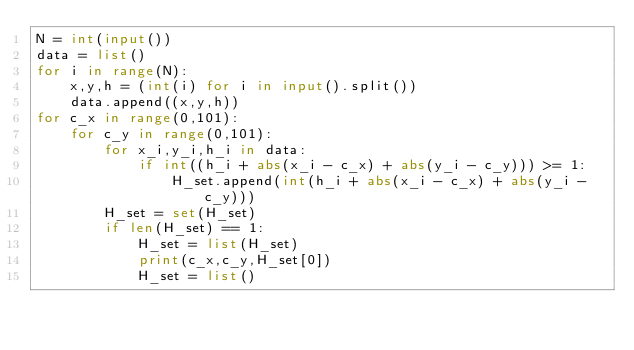<code> <loc_0><loc_0><loc_500><loc_500><_Python_>N = int(input())
data = list()
for i in range(N):
    x,y,h = (int(i) for i in input().split())
    data.append((x,y,h))
for c_x in range(0,101):
    for c_y in range(0,101):
        for x_i,y_i,h_i in data:
            if int((h_i + abs(x_i - c_x) + abs(y_i - c_y))) >= 1:
                H_set.append(int(h_i + abs(x_i - c_x) + abs(y_i - c_y)))
        H_set = set(H_set)
        if len(H_set) == 1:
            H_set = list(H_set)
            print(c_x,c_y,H_set[0])
            H_set = list()</code> 